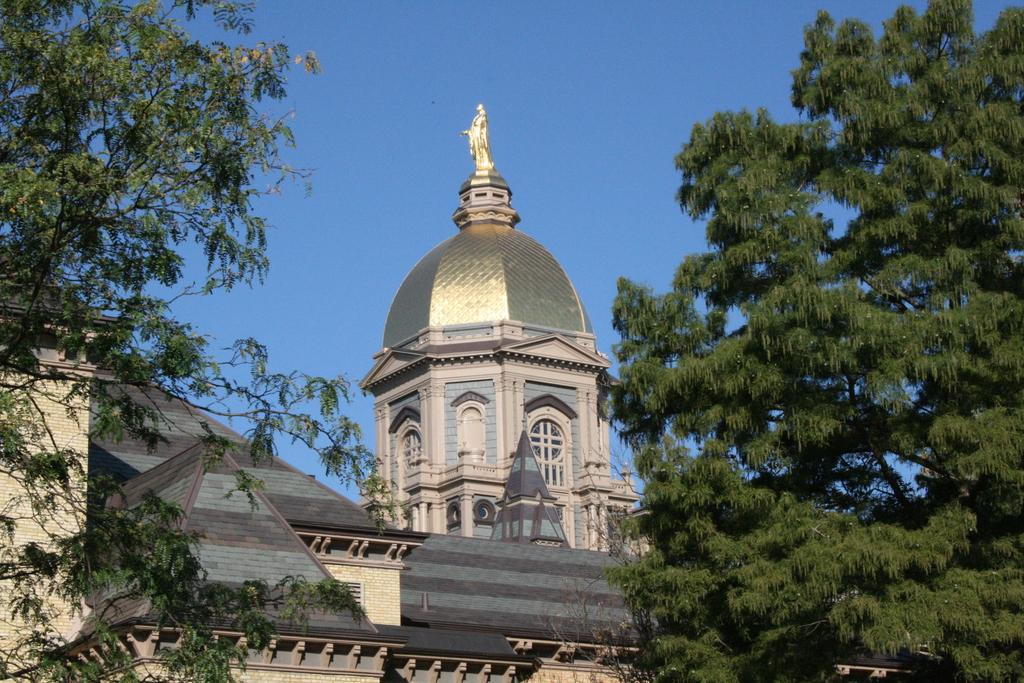What type of structure is present in the image? There is a building in the image. What other natural elements can be seen in the image? There are trees in the image. What part of the environment is visible in the image? The sky is visible in the image. What type of chain can be seen connecting the trees in the image? There is no chain present in the image; it only features a building, trees, and the sky. 